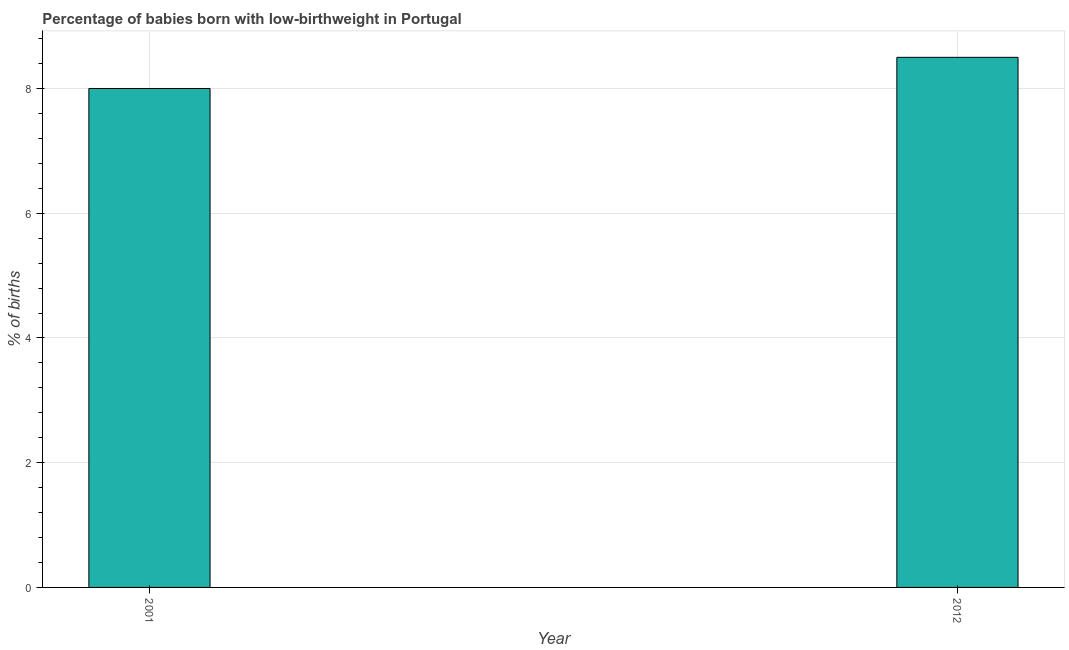What is the title of the graph?
Keep it short and to the point. Percentage of babies born with low-birthweight in Portugal. What is the label or title of the Y-axis?
Make the answer very short. % of births. Across all years, what is the maximum percentage of babies who were born with low-birthweight?
Ensure brevity in your answer.  8.5. What is the difference between the percentage of babies who were born with low-birthweight in 2001 and 2012?
Provide a succinct answer. -0.5. What is the average percentage of babies who were born with low-birthweight per year?
Provide a succinct answer. 8.25. What is the median percentage of babies who were born with low-birthweight?
Provide a short and direct response. 8.25. Do a majority of the years between 2001 and 2012 (inclusive) have percentage of babies who were born with low-birthweight greater than 6.4 %?
Provide a short and direct response. Yes. What is the ratio of the percentage of babies who were born with low-birthweight in 2001 to that in 2012?
Provide a succinct answer. 0.94. Are all the bars in the graph horizontal?
Keep it short and to the point. No. What is the difference between two consecutive major ticks on the Y-axis?
Ensure brevity in your answer.  2. Are the values on the major ticks of Y-axis written in scientific E-notation?
Keep it short and to the point. No. What is the % of births in 2012?
Provide a short and direct response. 8.5. What is the difference between the % of births in 2001 and 2012?
Your response must be concise. -0.5. What is the ratio of the % of births in 2001 to that in 2012?
Keep it short and to the point. 0.94. 